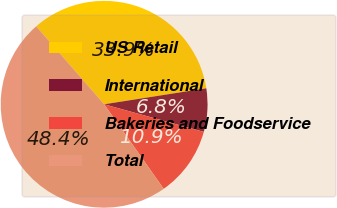<chart> <loc_0><loc_0><loc_500><loc_500><pie_chart><fcel>US Retail<fcel>International<fcel>Bakeries and Foodservice<fcel>Total<nl><fcel>33.92%<fcel>6.77%<fcel>10.93%<fcel>48.37%<nl></chart> 